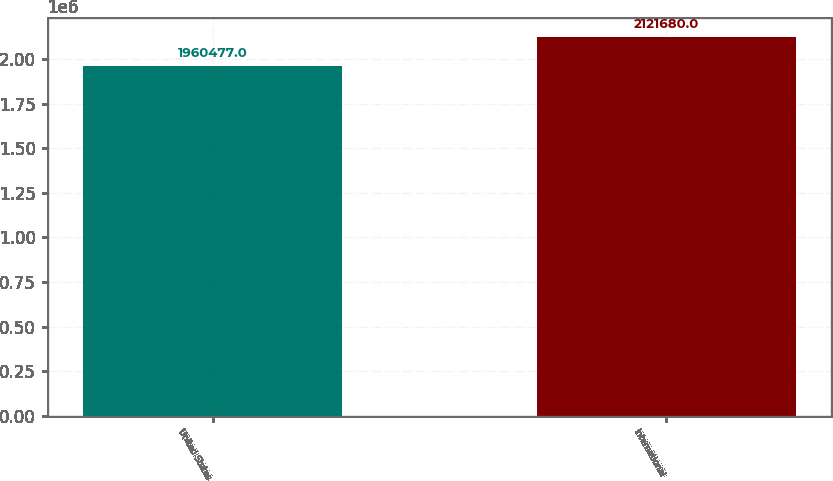Convert chart to OTSL. <chart><loc_0><loc_0><loc_500><loc_500><bar_chart><fcel>United States<fcel>International<nl><fcel>1.96048e+06<fcel>2.12168e+06<nl></chart> 